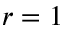Convert formula to latex. <formula><loc_0><loc_0><loc_500><loc_500>r = 1</formula> 